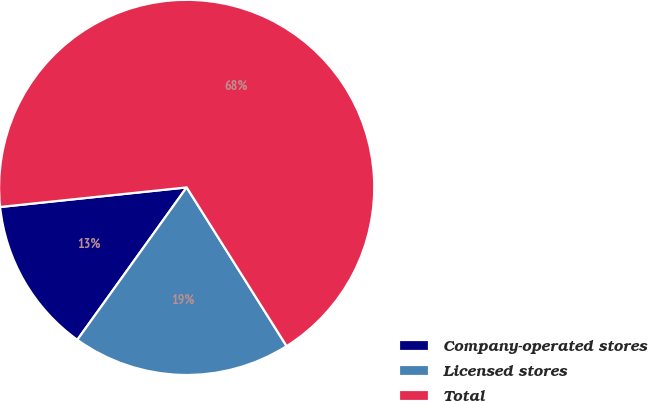Convert chart. <chart><loc_0><loc_0><loc_500><loc_500><pie_chart><fcel>Company-operated stores<fcel>Licensed stores<fcel>Total<nl><fcel>13.43%<fcel>18.85%<fcel>67.72%<nl></chart> 